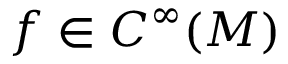<formula> <loc_0><loc_0><loc_500><loc_500>f \in C ^ { \infty } ( M )</formula> 